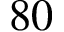Convert formula to latex. <formula><loc_0><loc_0><loc_500><loc_500>8 0</formula> 